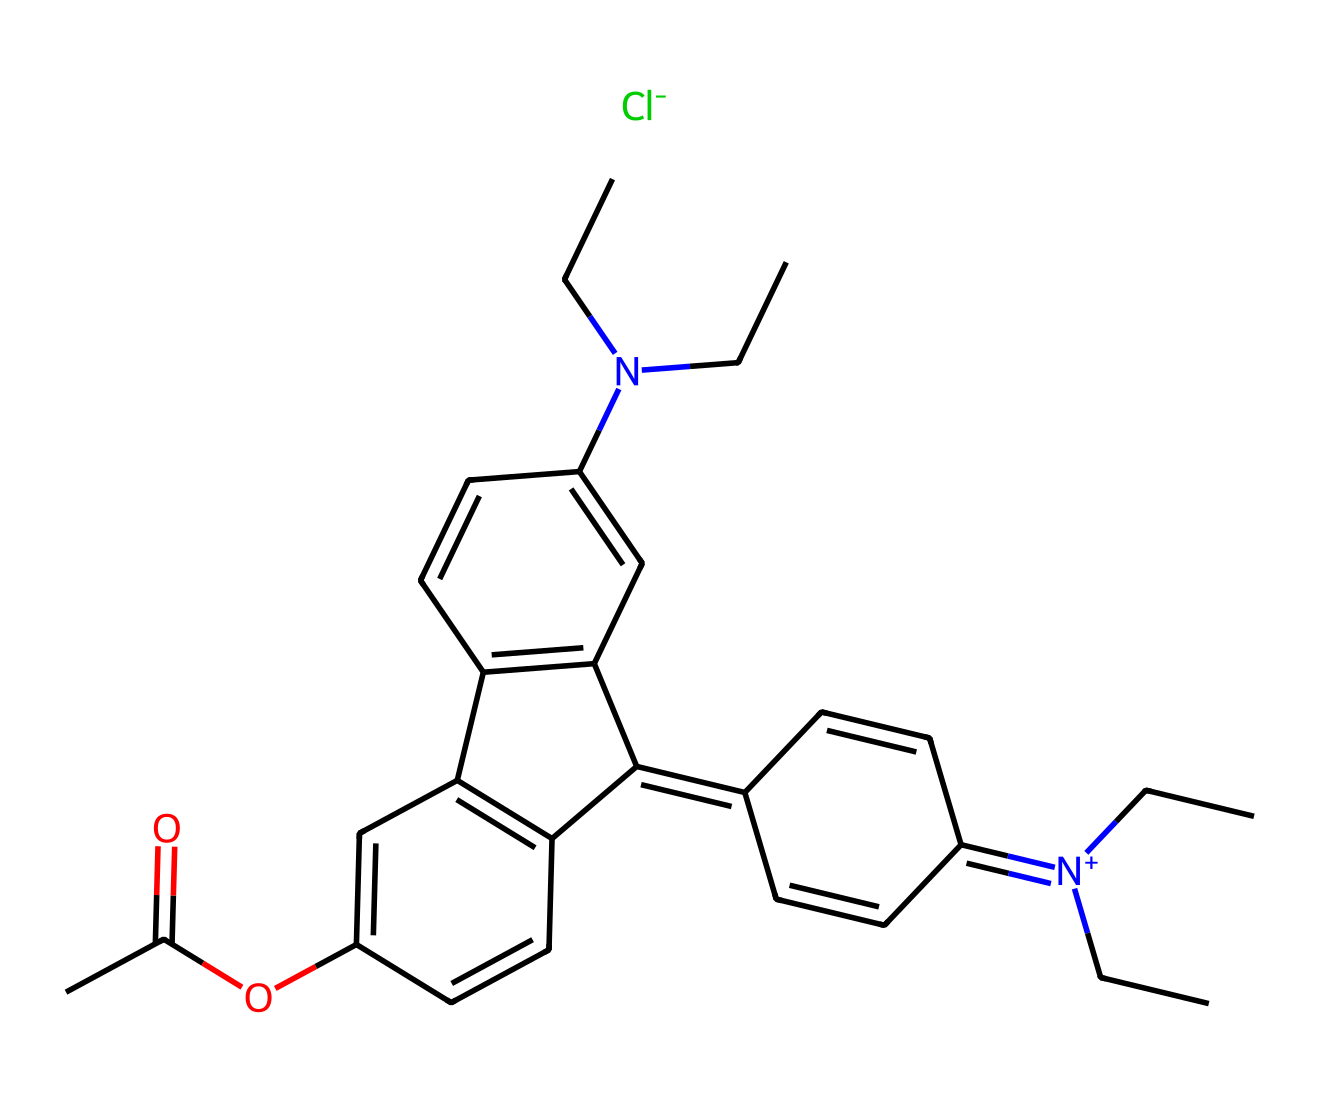What is the molecular formula of rhodamine B? To find the molecular formula, count the number of each type of atom in the SMILES representation. The compound consists of 27 carbons, 31 hydrogens, 2 nitrogens, and 1 oxygen, leading to the formula C27H31N2O.
Answer: C27H31N2O How many nitrogen atoms are present in rhodamine B? By analyzing the SMILES string, we can identify two nitrogen atoms indicated by 'N' in the structure.
Answer: 2 What type of chemical bond connects nitrogen to carbon in rhodamine B? The nitrogen atoms in this structure are connected to carbon through single bonds, as inferred from the connectivity in the SMILES format.
Answer: single bonds Which group in rhodamine B contributes to its fluorescence property? The xanthene structure and the adjacent nitrogen and carbon arrangement create a system conducive to fluorescence. This conjugated system allows for extensive electron delocalization, leading to fluorescence.
Answer: xanthene group Is rhodamine B cationic or anionic under physiological conditions? The presence of a positively charged nitrogen atom group '[N+](CC)CC' in the structure indicates that rhodamine B behaves as a cationic dye in physiological conditions.
Answer: cationic What is the likely color of rhodamine B in solution? Given that rhodamine B is known to emit strongly in the green to red region, the compound is typically observed as a bright pink to red in solution.
Answer: pink What functional group is indicated by 'CC(=O)O' in rhodamine B? This part of the SMILES representation shows an ester functional group, where the oxygen connects to carbon via a carbonyl and an alkyl chain.
Answer: ester 